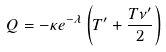Convert formula to latex. <formula><loc_0><loc_0><loc_500><loc_500>Q = - \kappa e ^ { - \lambda } \left ( T ^ { \prime } + \frac { T \nu ^ { \prime } } { 2 } \right )</formula> 